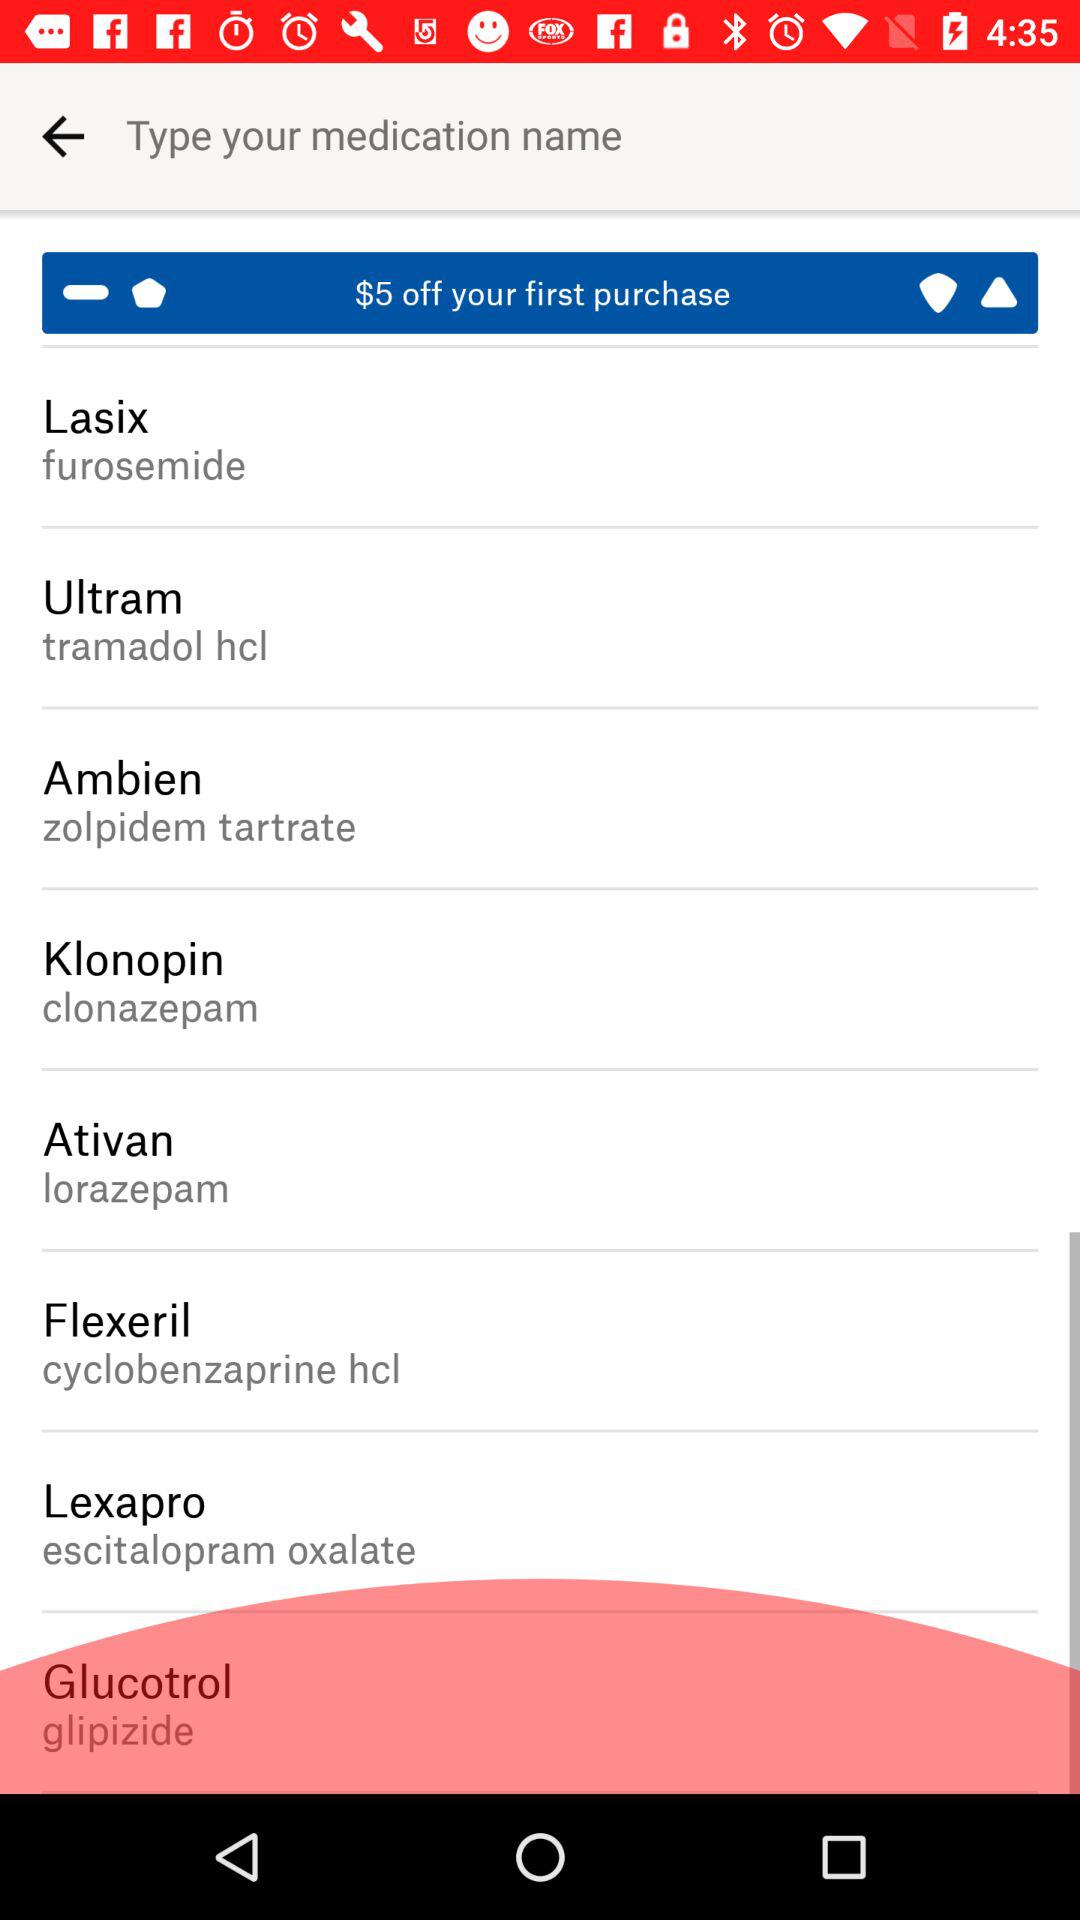How much is off on the first purchase? On the first purchase, $5 is off. 